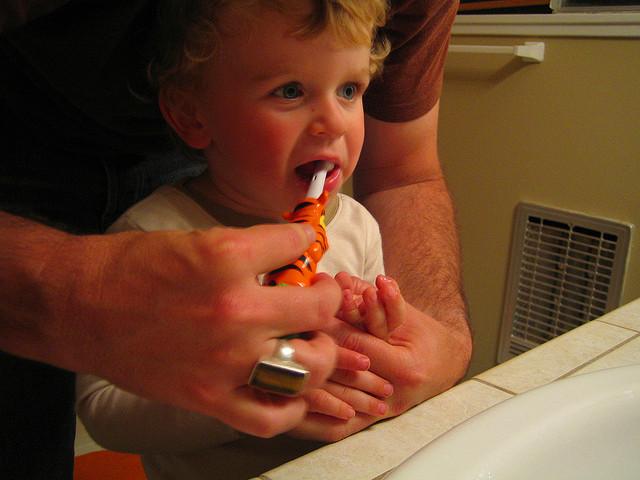Is there someone sitting?
Concise answer only. No. What is this child doing?
Give a very brief answer. Brushing teeth. What is the boy doing?
Keep it brief. Brushing teeth. Is the child brushing his teeth?
Quick response, please. Yes. Where was the photo taken?
Quick response, please. Bathroom. What is the baby doing?
Be succinct. Brushing teeth. How many people are in the photo?
Concise answer only. 2. Is  the kid's hair curly?
Short answer required. Yes. Is the person wearing a wedding band?
Concise answer only. No. 